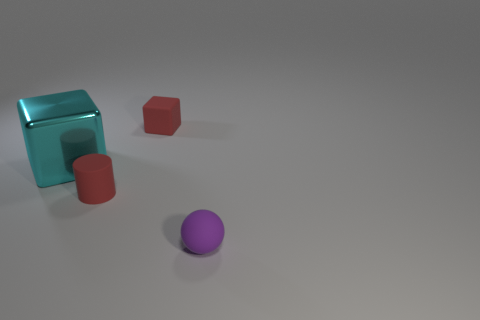Are there the same number of red matte cylinders that are in front of the cylinder and red things to the right of the big shiny cube?
Keep it short and to the point. No. How many purple objects are the same size as the red cube?
Offer a terse response. 1. What number of purple things are either rubber balls or big metal cubes?
Offer a very short reply. 1. Are there an equal number of small matte things behind the big cyan block and large cyan cylinders?
Make the answer very short. No. What size is the cube on the left side of the small block?
Your answer should be compact. Large. What number of tiny rubber things have the same shape as the cyan metal object?
Offer a very short reply. 1. There is a object that is behind the small cylinder and to the left of the rubber cube; what material is it made of?
Keep it short and to the point. Metal. Is the material of the tiny cube the same as the purple thing?
Offer a terse response. Yes. What number of red matte cubes are there?
Offer a terse response. 1. There is a rubber thing to the right of the small red matte thing that is behind the red object that is in front of the big cyan object; what color is it?
Make the answer very short. Purple. 